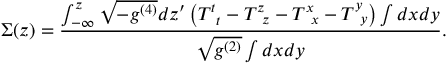<formula> <loc_0><loc_0><loc_500><loc_500>\Sigma ( z ) = \frac { \int _ { - \infty } ^ { z } \sqrt { - g ^ { ( 4 ) } } d z ^ { \prime } \left ( T _ { \, t } ^ { t } - T _ { \, z } ^ { z } - T _ { \, x } ^ { x } - T _ { \, y } ^ { y } \right ) \int d x d y } { \sqrt { g ^ { ( 2 ) } } \int d x d y } .</formula> 